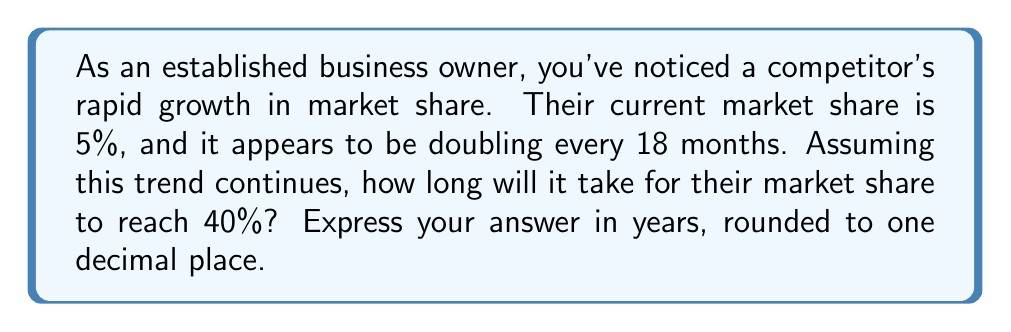Teach me how to tackle this problem. Let's approach this problem using an exponential growth model:

1) Let $P(t)$ be the market share after $t$ years, where $P(0) = 5\%$ (initial market share).

2) The growth rate $r$ can be calculated as follows:
   $2 = e^{r(1.5)}$ (doubling every 18 months = 1.5 years)
   $\ln(2) = 1.5r$
   $r = \frac{\ln(2)}{1.5} \approx 0.4621$ per year

3) The exponential growth function is:
   $P(t) = 5e^{0.4621t}$

4) We want to find $t$ when $P(t) = 40\%$:
   $40 = 5e^{0.4621t}$

5) Solving for $t$:
   $8 = e^{0.4621t}$
   $\ln(8) = 0.4621t$
   $t = \frac{\ln(8)}{0.4621} \approx 4.5085$ years

6) Rounding to one decimal place: 4.5 years

This calculation shows how exponential growth can lead to rapid market share increases, demonstrating the potential threat to an established business owner.
Answer: 4.5 years 